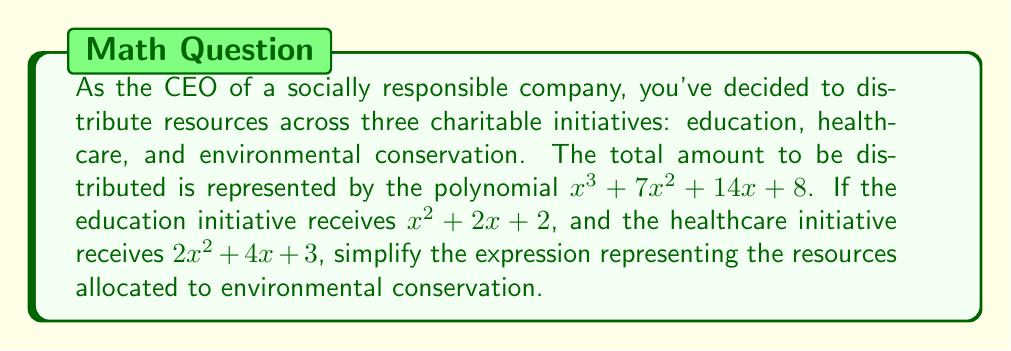Can you solve this math problem? To solve this problem, we need to follow these steps:

1) First, let's recall that the total resources are represented by $x^3 + 7x^2 + 14x + 8$.

2) The resources allocated to education are $x^2 + 2x + 2$.

3) The resources allocated to healthcare are $2x^2 + 4x + 3$.

4) To find the resources allocated to environmental conservation, we need to subtract the resources allocated to education and healthcare from the total resources.

5) Let's set up the equation:
   Environmental Conservation = Total - Education - Healthcare
   $$(x^3 + 7x^2 + 14x + 8) - (x^2 + 2x + 2) - (2x^2 + 4x + 3)$$

6) Now, let's simplify by combining like terms:
   $x^3 + 7x^2 + 14x + 8$
   $- x^2 - 2x - 2$
   $- 2x^2 - 4x - 3$
   
   $= x^3 + (7-1-2)x^2 + (14-2-4)x + (8-2-3)$
   
   $= x^3 + 4x^2 + 8x + 3$

7) This simplified polynomial represents the resources allocated to environmental conservation.
Answer: $x^3 + 4x^2 + 8x + 3$ 